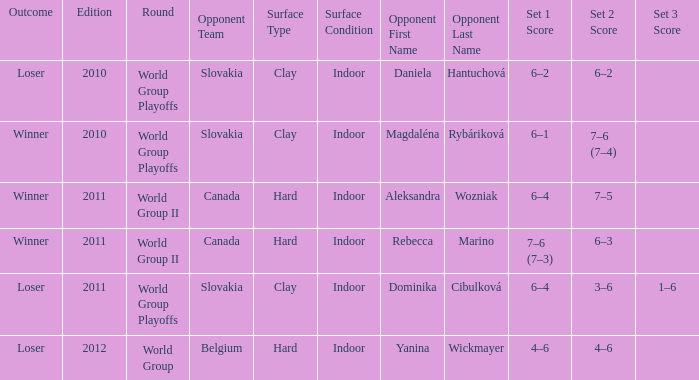What was the result of the game when the adversary was magdaléna rybáriková? Winner. 